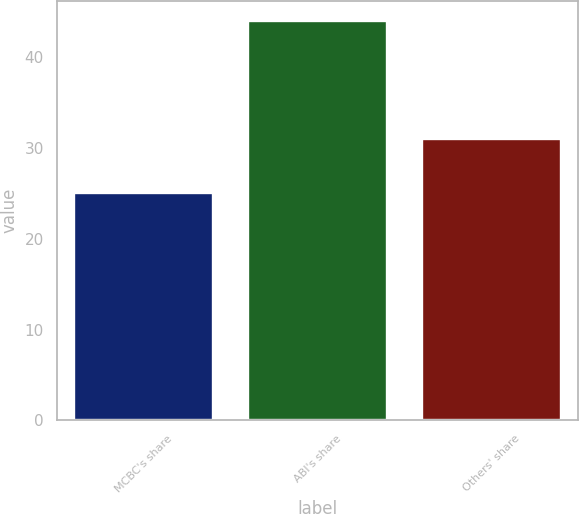<chart> <loc_0><loc_0><loc_500><loc_500><bar_chart><fcel>MCBC's share<fcel>ABI's share<fcel>Others' share<nl><fcel>25<fcel>44<fcel>31<nl></chart> 